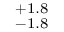Convert formula to latex. <formula><loc_0><loc_0><loc_500><loc_500>^ { + 1 . 8 } _ { - 1 . 8 }</formula> 